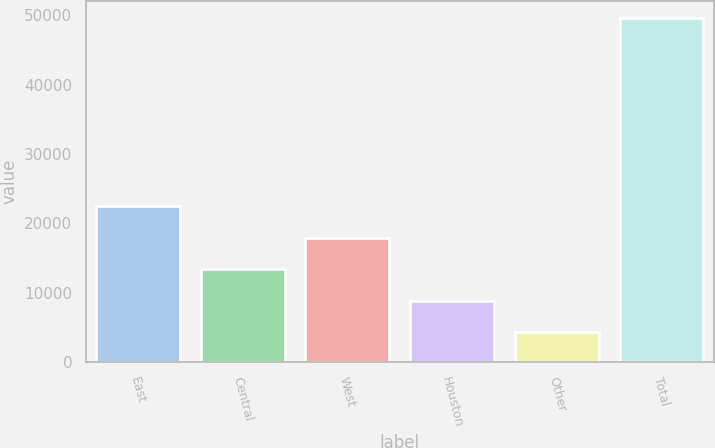Convert chart to OTSL. <chart><loc_0><loc_0><loc_500><loc_500><bar_chart><fcel>East<fcel>Central<fcel>West<fcel>Houston<fcel>Other<fcel>Total<nl><fcel>22411.4<fcel>13359.2<fcel>17885.3<fcel>8833.1<fcel>4307<fcel>49568<nl></chart> 